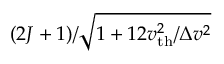Convert formula to latex. <formula><loc_0><loc_0><loc_500><loc_500>( 2 J + 1 ) / \sqrt { 1 + 1 2 v _ { t h } ^ { 2 } / \Delta v ^ { 2 } }</formula> 